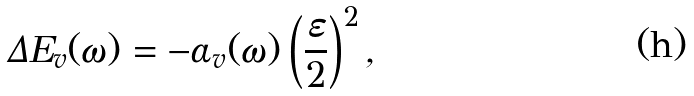<formula> <loc_0><loc_0><loc_500><loc_500>\Delta E _ { v } ( \omega ) = - \alpha _ { v } ( \omega ) \left ( \frac { \varepsilon } { 2 } \right ) ^ { 2 } ,</formula> 